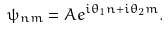Convert formula to latex. <formula><loc_0><loc_0><loc_500><loc_500>\psi _ { n m } = A e ^ { i \theta _ { 1 } n + i \theta _ { 2 } m } .</formula> 